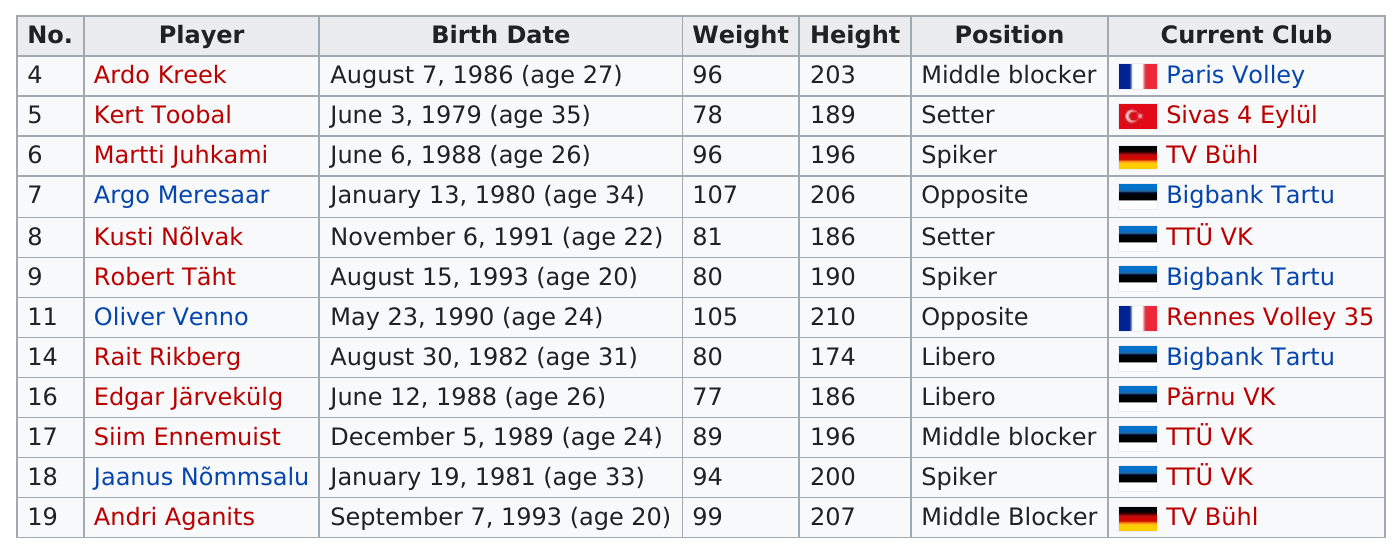Identify some key points in this picture. In total, there are 2 players from France. Oliver Venno is taller than Rait Rikberg by 36 inches. Of the members of Estonia's men's national volleyball team, two were born in 1988. At least one person on the list is 25 years old or older: Ardo Kreek, Kert Toobal, Martti Juhkami, Argo Meresaar, Rait Rikberg, Edgar Järvekülg, Jaanus Nõmmsalu. Oliver Venno, a player on Estonia's men's national volleyball team, is taller than Andri Aganits. 